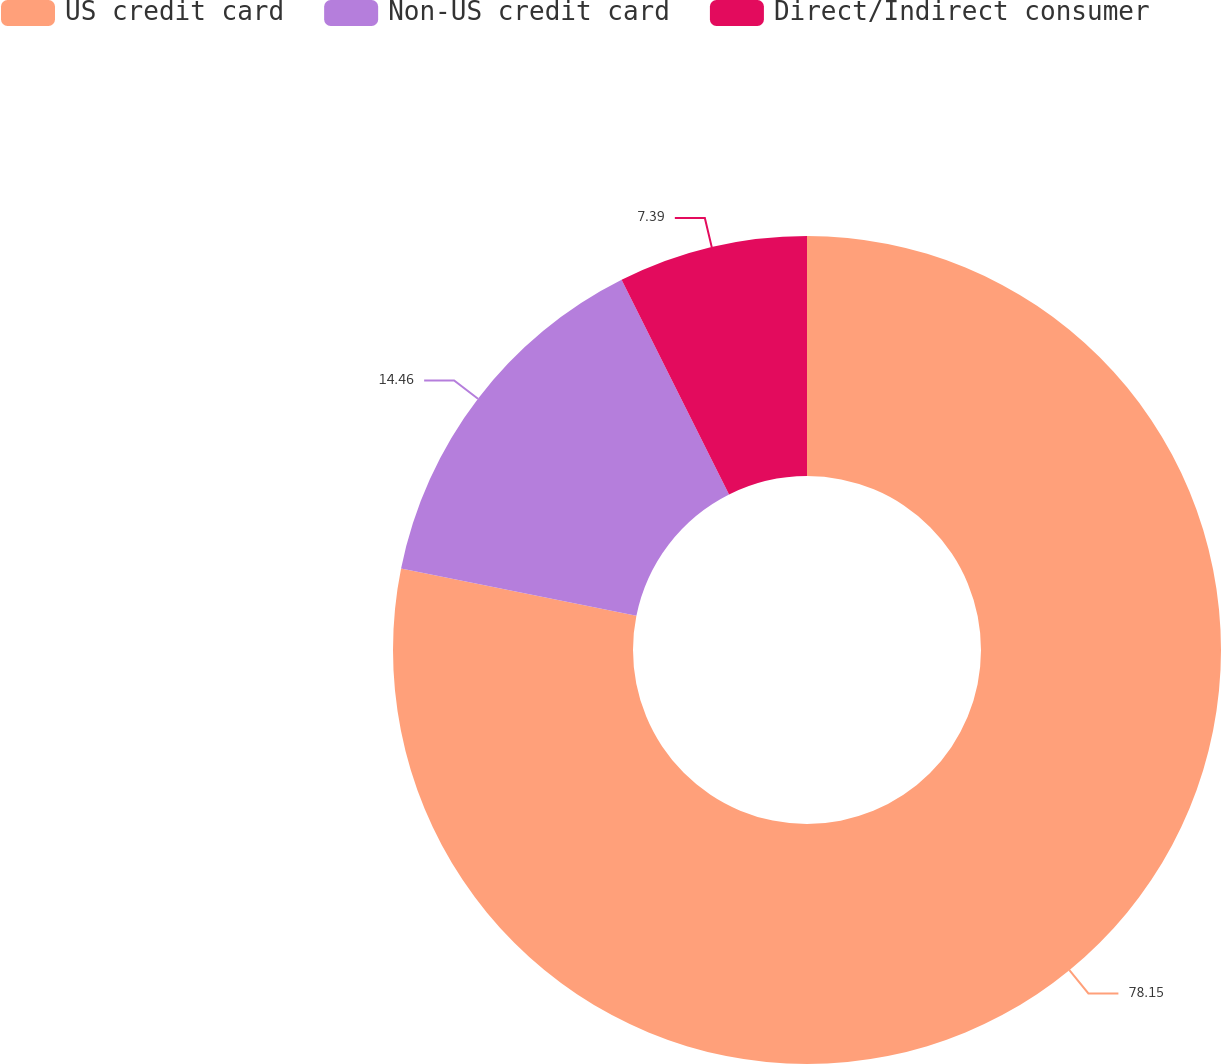<chart> <loc_0><loc_0><loc_500><loc_500><pie_chart><fcel>US credit card<fcel>Non-US credit card<fcel>Direct/Indirect consumer<nl><fcel>78.15%<fcel>14.46%<fcel>7.39%<nl></chart> 